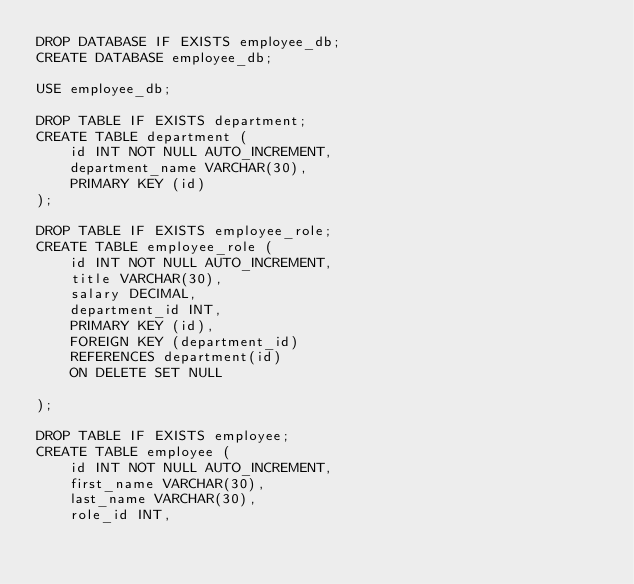Convert code to text. <code><loc_0><loc_0><loc_500><loc_500><_SQL_>DROP DATABASE IF EXISTS employee_db;
CREATE DATABASE employee_db;

USE employee_db;

DROP TABLE IF EXISTS department;
CREATE TABLE department (
    id INT NOT NULL AUTO_INCREMENT,
    department_name VARCHAR(30),
    PRIMARY KEY (id)
);

DROP TABLE IF EXISTS employee_role;
CREATE TABLE employee_role (
    id INT NOT NULL AUTO_INCREMENT,
    title VARCHAR(30),
    salary DECIMAL,
    department_id INT,
    PRIMARY KEY (id),
    FOREIGN KEY (department_id)
    REFERENCES department(id)
    ON DELETE SET NULL

);

DROP TABLE IF EXISTS employee;
CREATE TABLE employee (
    id INT NOT NULL AUTO_INCREMENT,
    first_name VARCHAR(30),
    last_name VARCHAR(30),
    role_id INT,</code> 